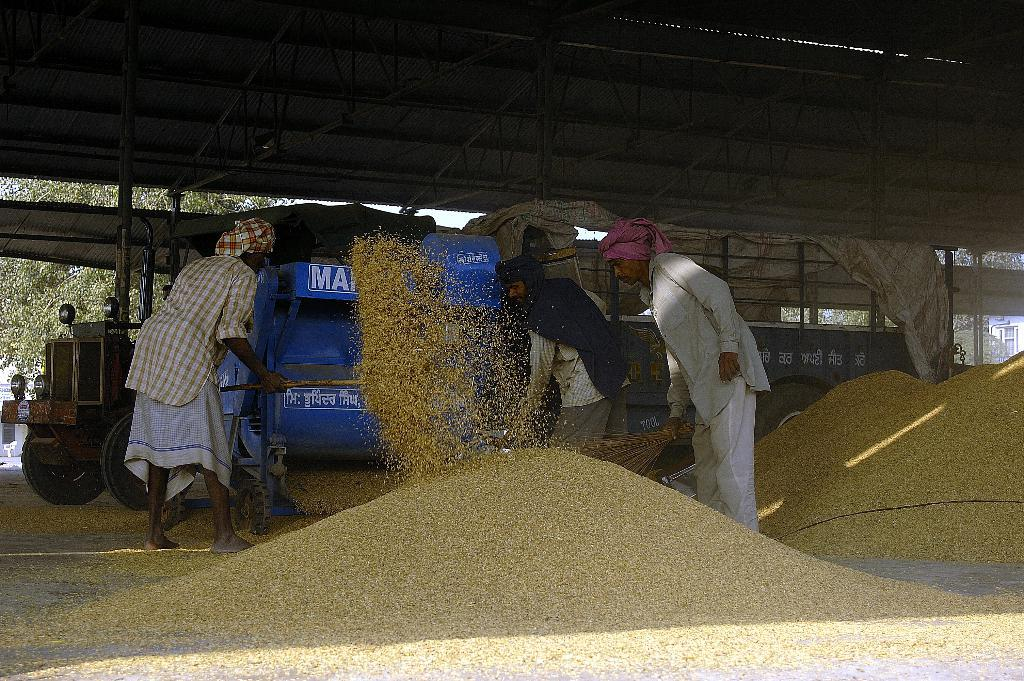Who or what can be seen in the image? There are people in the image. What type of agricultural product can be seen in the image? There are grains visible in the image. What mode of transportation is present in the image? A vehicle is present in the image. What type of equipment is present in the image? There is a machine in the image. What type of structures can be seen in the image? There are sheds in the image. What can be seen in the background of the image? Trees and the sky are visible in the background of the image. How many friends are visible in the image? There is no mention of friends in the image; it features people, grains, a vehicle, a machine, sheds, trees, and the sky. What type of addition problem can be solved using the grains in the image? There is no addition problem present in the image; it simply shows grains. 